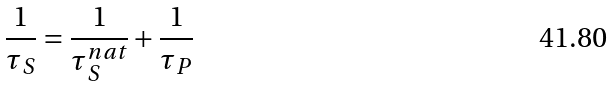<formula> <loc_0><loc_0><loc_500><loc_500>\frac { 1 } { \tau _ { S } } = \frac { 1 } { \tau _ { S } ^ { n a t } } + \frac { 1 } { \tau _ { P } }</formula> 